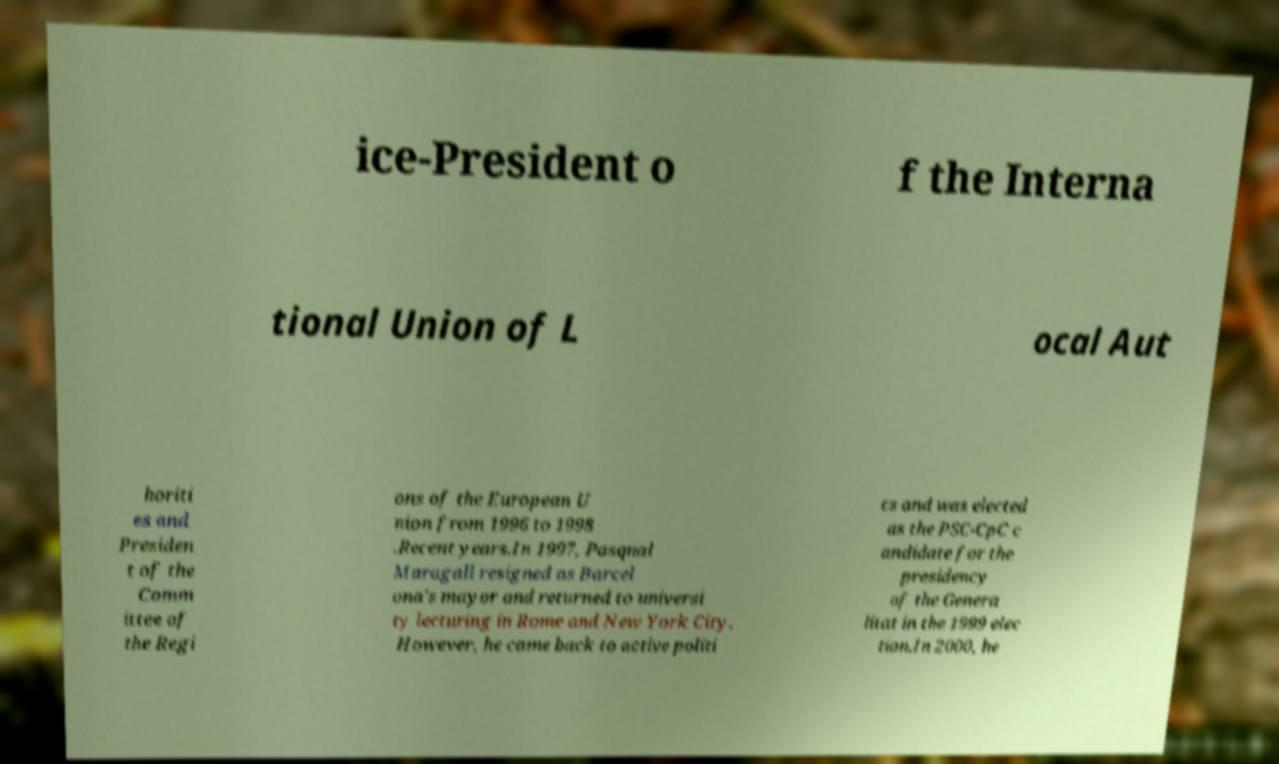Can you read and provide the text displayed in the image?This photo seems to have some interesting text. Can you extract and type it out for me? ice-President o f the Interna tional Union of L ocal Aut horiti es and Presiden t of the Comm ittee of the Regi ons of the European U nion from 1996 to 1998 .Recent years.In 1997, Pasqual Maragall resigned as Barcel ona's mayor and returned to universi ty lecturing in Rome and New York City. However, he came back to active politi cs and was elected as the PSC-CpC c andidate for the presidency of the Genera litat in the 1999 elec tion.In 2000, he 